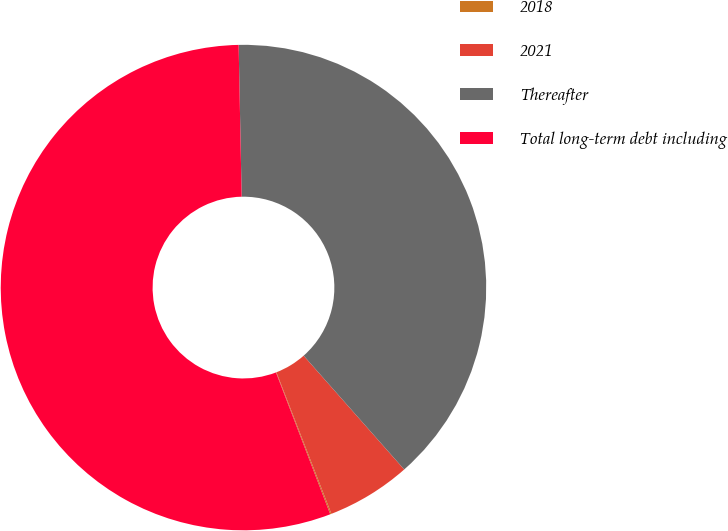<chart> <loc_0><loc_0><loc_500><loc_500><pie_chart><fcel>2018<fcel>2021<fcel>Thereafter<fcel>Total long-term debt including<nl><fcel>0.08%<fcel>5.62%<fcel>38.8%<fcel>55.5%<nl></chart> 